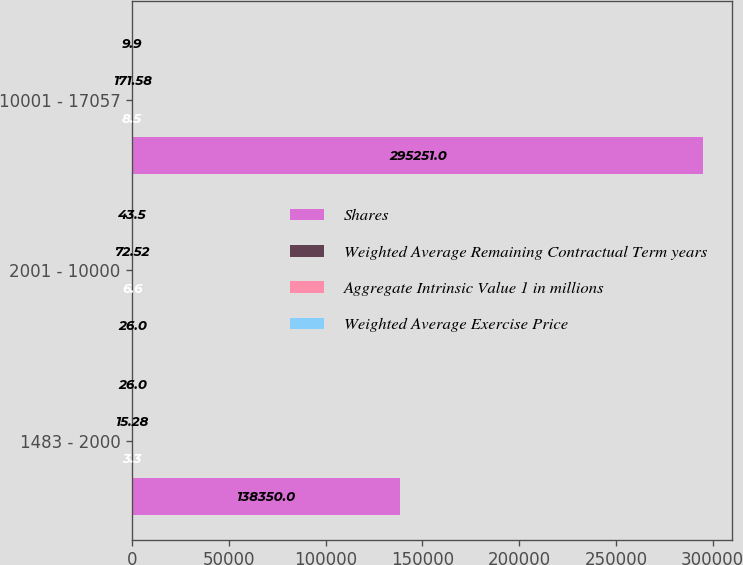Convert chart. <chart><loc_0><loc_0><loc_500><loc_500><stacked_bar_chart><ecel><fcel>1483 - 2000<fcel>2001 - 10000<fcel>10001 - 17057<nl><fcel>Shares<fcel>138350<fcel>26<fcel>295251<nl><fcel>Weighted Average Remaining Contractual Term years<fcel>3.3<fcel>6.6<fcel>8.5<nl><fcel>Aggregate Intrinsic Value 1 in millions<fcel>15.28<fcel>72.52<fcel>171.58<nl><fcel>Weighted Average Exercise Price<fcel>26<fcel>43.5<fcel>9.9<nl></chart> 